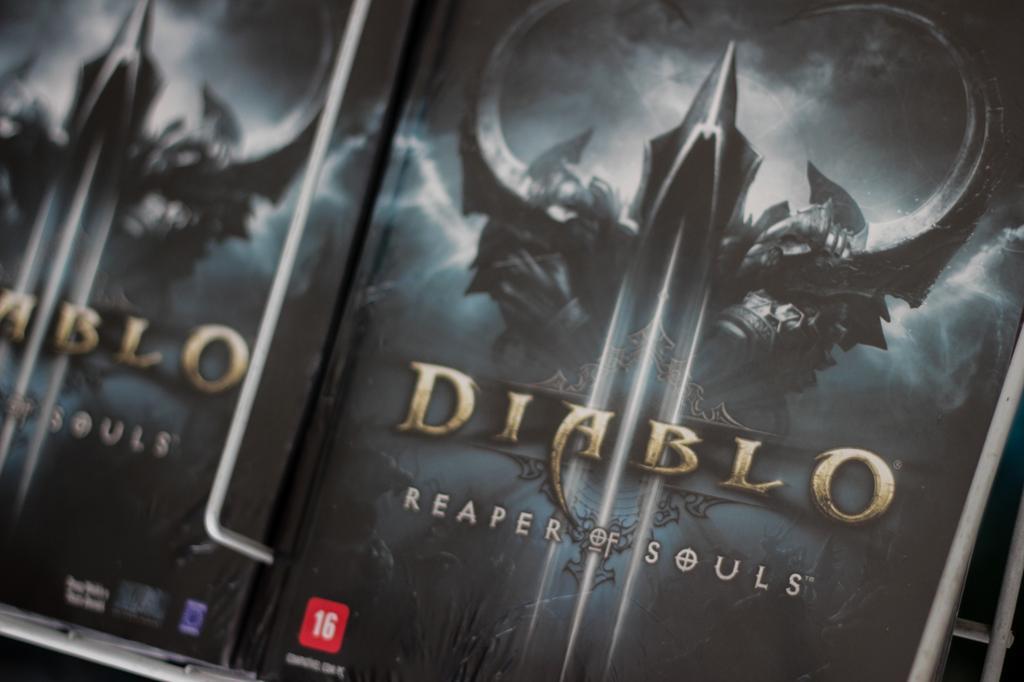Can you describe this image briefly? In this image we can see books in a shelf. 